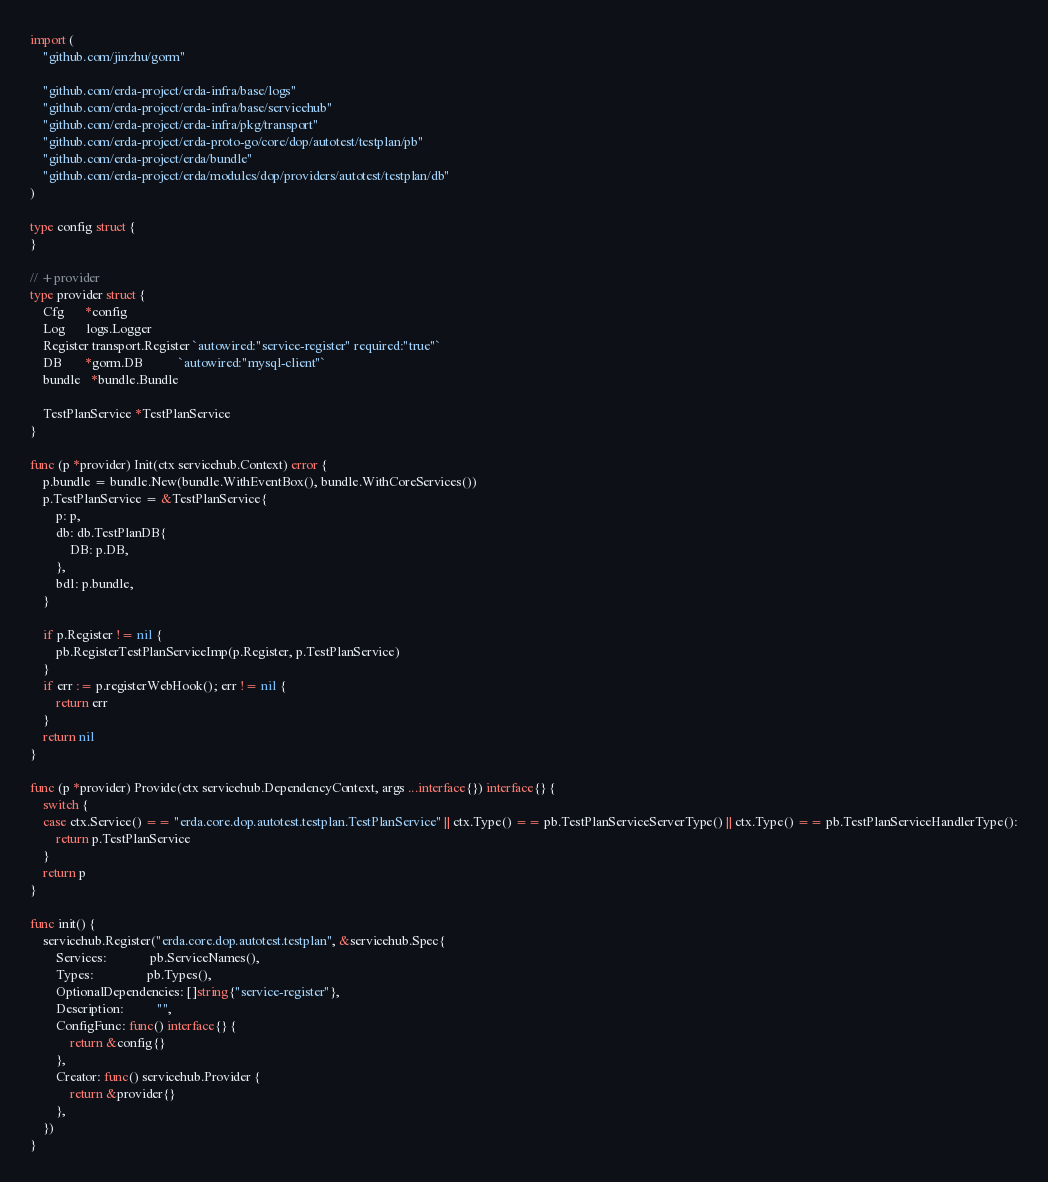Convert code to text. <code><loc_0><loc_0><loc_500><loc_500><_Go_>import (
	"github.com/jinzhu/gorm"

	"github.com/erda-project/erda-infra/base/logs"
	"github.com/erda-project/erda-infra/base/servicehub"
	"github.com/erda-project/erda-infra/pkg/transport"
	"github.com/erda-project/erda-proto-go/core/dop/autotest/testplan/pb"
	"github.com/erda-project/erda/bundle"
	"github.com/erda-project/erda/modules/dop/providers/autotest/testplan/db"
)

type config struct {
}

// +provider
type provider struct {
	Cfg      *config
	Log      logs.Logger
	Register transport.Register `autowired:"service-register" required:"true"`
	DB       *gorm.DB           `autowired:"mysql-client"`
	bundle   *bundle.Bundle

	TestPlanService *TestPlanService
}

func (p *provider) Init(ctx servicehub.Context) error {
	p.bundle = bundle.New(bundle.WithEventBox(), bundle.WithCoreServices())
	p.TestPlanService = &TestPlanService{
		p: p,
		db: db.TestPlanDB{
			DB: p.DB,
		},
		bdl: p.bundle,
	}

	if p.Register != nil {
		pb.RegisterTestPlanServiceImp(p.Register, p.TestPlanService)
	}
	if err := p.registerWebHook(); err != nil {
		return err
	}
	return nil
}

func (p *provider) Provide(ctx servicehub.DependencyContext, args ...interface{}) interface{} {
	switch {
	case ctx.Service() == "erda.core.dop.autotest.testplan.TestPlanService" || ctx.Type() == pb.TestPlanServiceServerType() || ctx.Type() == pb.TestPlanServiceHandlerType():
		return p.TestPlanService
	}
	return p
}

func init() {
	servicehub.Register("erda.core.dop.autotest.testplan", &servicehub.Spec{
		Services:             pb.ServiceNames(),
		Types:                pb.Types(),
		OptionalDependencies: []string{"service-register"},
		Description:          "",
		ConfigFunc: func() interface{} {
			return &config{}
		},
		Creator: func() servicehub.Provider {
			return &provider{}
		},
	})
}
</code> 